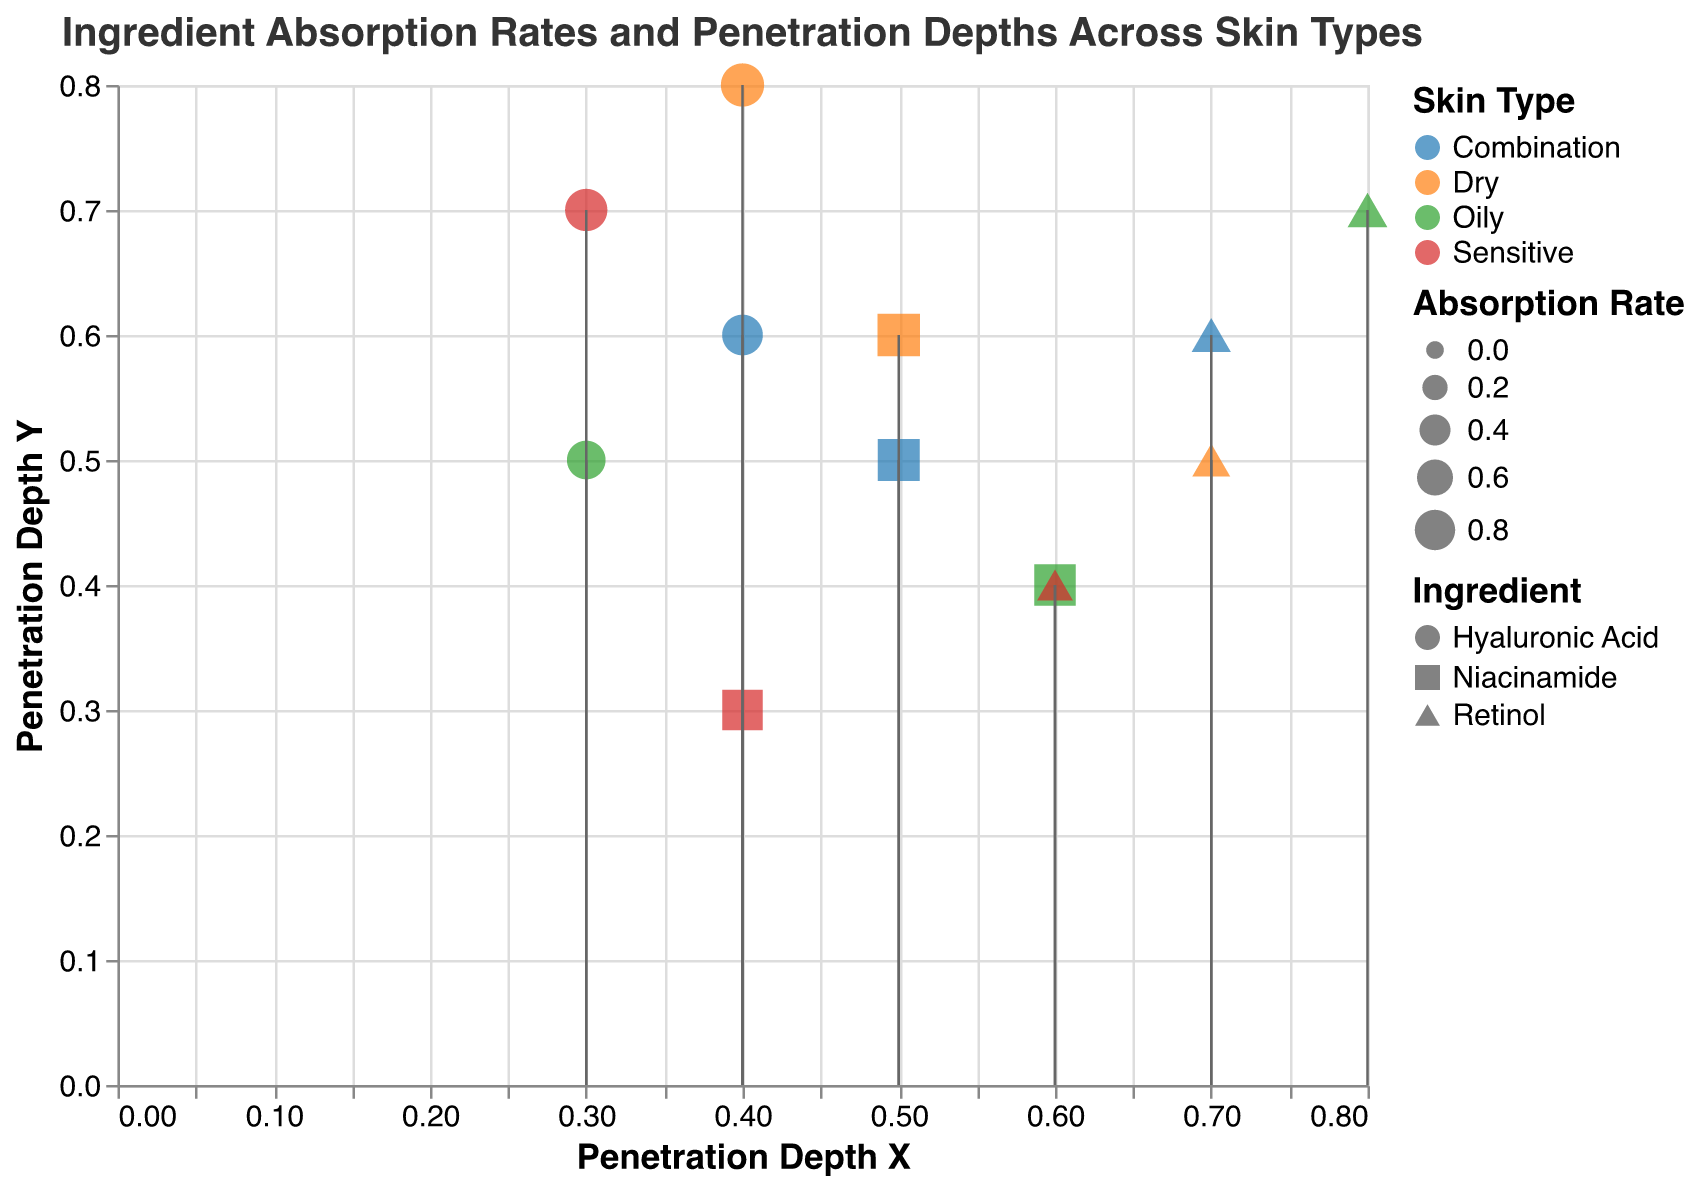What is the title of the plot? The title of the plot is located at the top of the figure. By directly reading the text, you can identify it.
Answer: Ingredient Absorption Rates and Penetration Depths Across Skin Types Which ingredient has the highest absorption rate in dry skin types? Identify the points for the "Dry" skin type using the color legend, then compare the sizes of the points (which represent the absorption rates) for Niacinamide, Hyaluronic Acid, and Retinol. Hyaluronic Acid has the largest size.
Answer: Hyaluronic Acid What are the penetration depths for Niacinamide in oily skin type? Locate the Niacinamide data points for "Oily" skin type using the shape and color legends, then read off the x and y values for penetration depth.
Answer: 0.6 (x), 0.4 (y) Which skin type generally shows the highest absorption rates across ingredients? Compare the sizes of the points (which represent the absorption rates) across all skin types by referencing the color legend.
Answer: Dry For sensitive skin, which ingredient shows the least penetration depth x? Identify the points for "Sensitive" skin type using the color legend, then check the x values for Niacinamide, Hyaluronic Acid, and Retinol. Hyaluronic Acid has the lowest x value.
Answer: Hyaluronic Acid Which combination of ingredient and skin type shows the deepest penetration depth y? Scan all the points for the highest y value and identify the corresponding skin type and ingredient from the shape and color legends.
Answer: Dry, Hyaluronic Acid Is the absorption rate for Retinol higher in oily or sensitive skin types? Compare the sizes of the Retinol points for "Oily" and "Sensitive" skin types by using the shape and color legends. The point size for "Oily" is larger.
Answer: Oily What are the general trends observed in penetration depth x and y for Hyaluronic Acid across different skin types? Observe the plotted points for Hyaluronic Acid across all skin types using the shape legend and note the x and y positions. Hyaluronic Acid generally shows lower x values and varying y values.
Answer: Lower x, varying y Which ingredient exhibits the highest variation in absorption rates across different skin types? Compare the sizes of the points for each ingredient across all skin types. Retinol has the most variation in point sizes.
Answer: Retinol 